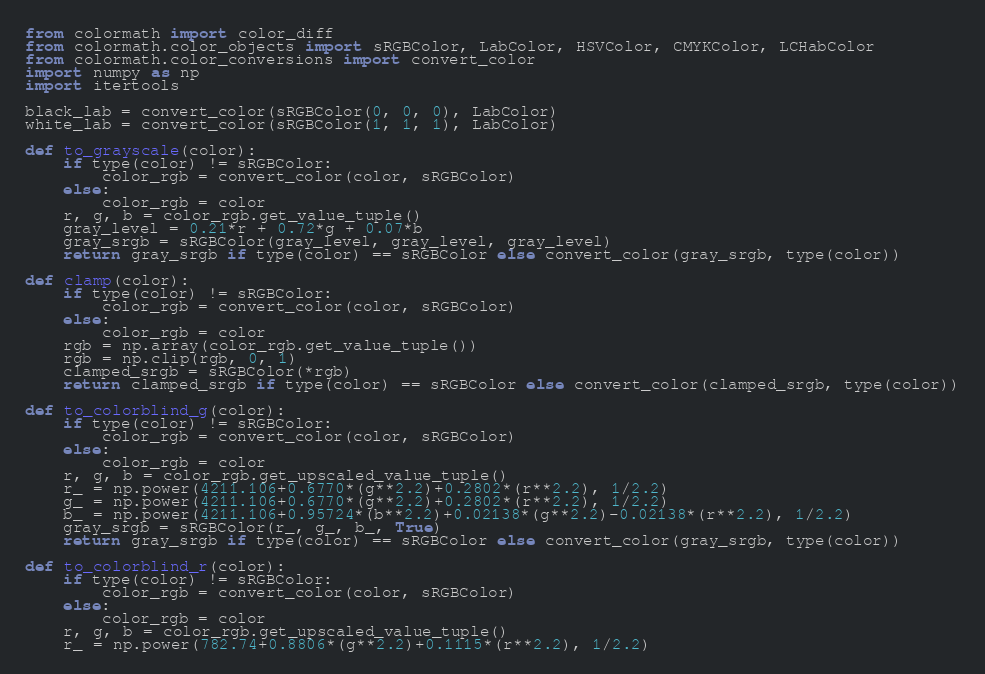Convert code to text. <code><loc_0><loc_0><loc_500><loc_500><_Python_>from colormath import color_diff
from colormath.color_objects import sRGBColor, LabColor, HSVColor, CMYKColor, LCHabColor
from colormath.color_conversions import convert_color
import numpy as np
import itertools

black_lab = convert_color(sRGBColor(0, 0, 0), LabColor)
white_lab = convert_color(sRGBColor(1, 1, 1), LabColor)

def to_grayscale(color):
    if type(color) != sRGBColor:
        color_rgb = convert_color(color, sRGBColor)
    else:
        color_rgb = color
    r, g, b = color_rgb.get_value_tuple()
    gray_level = 0.21*r + 0.72*g + 0.07*b
    gray_srgb = sRGBColor(gray_level, gray_level, gray_level)
    return gray_srgb if type(color) == sRGBColor else convert_color(gray_srgb, type(color))

def clamp(color):
    if type(color) != sRGBColor:
        color_rgb = convert_color(color, sRGBColor)
    else:
        color_rgb = color
    rgb = np.array(color_rgb.get_value_tuple())
    rgb = np.clip(rgb, 0, 1)
    clamped_srgb = sRGBColor(*rgb)
    return clamped_srgb if type(color) == sRGBColor else convert_color(clamped_srgb, type(color))

def to_colorblind_g(color):
    if type(color) != sRGBColor:
        color_rgb = convert_color(color, sRGBColor)
    else:
        color_rgb = color
    r, g, b = color_rgb.get_upscaled_value_tuple()
    r_ = np.power(4211.106+0.6770*(g**2.2)+0.2802*(r**2.2), 1/2.2)
    g_ = np.power(4211.106+0.6770*(g**2.2)+0.2802*(r**2.2), 1/2.2)
    b_ = np.power(4211.106+0.95724*(b**2.2)+0.02138*(g**2.2)-0.02138*(r**2.2), 1/2.2)
    gray_srgb = sRGBColor(r_, g_, b_, True)
    return gray_srgb if type(color) == sRGBColor else convert_color(gray_srgb, type(color))

def to_colorblind_r(color):
    if type(color) != sRGBColor:
        color_rgb = convert_color(color, sRGBColor)
    else:
        color_rgb = color
    r, g, b = color_rgb.get_upscaled_value_tuple()
    r_ = np.power(782.74+0.8806*(g**2.2)+0.1115*(r**2.2), 1/2.2)</code> 